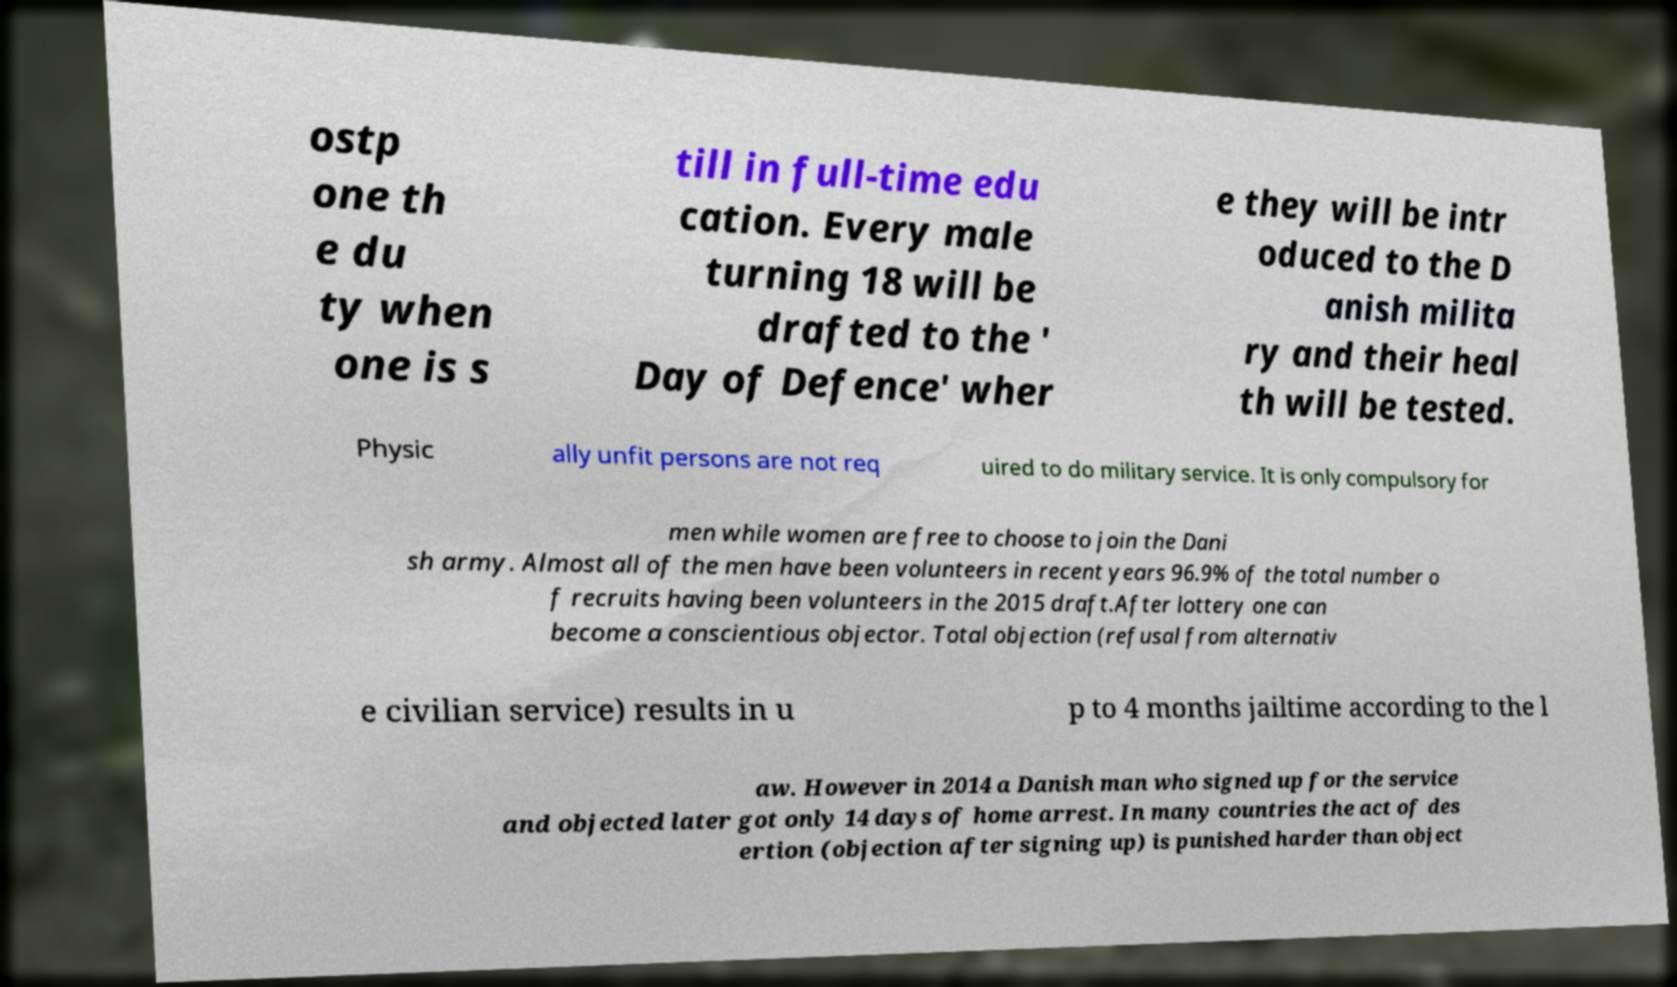Please read and relay the text visible in this image. What does it say? ostp one th e du ty when one is s till in full-time edu cation. Every male turning 18 will be drafted to the ' Day of Defence' wher e they will be intr oduced to the D anish milita ry and their heal th will be tested. Physic ally unfit persons are not req uired to do military service. It is only compulsory for men while women are free to choose to join the Dani sh army. Almost all of the men have been volunteers in recent years 96.9% of the total number o f recruits having been volunteers in the 2015 draft.After lottery one can become a conscientious objector. Total objection (refusal from alternativ e civilian service) results in u p to 4 months jailtime according to the l aw. However in 2014 a Danish man who signed up for the service and objected later got only 14 days of home arrest. In many countries the act of des ertion (objection after signing up) is punished harder than object 